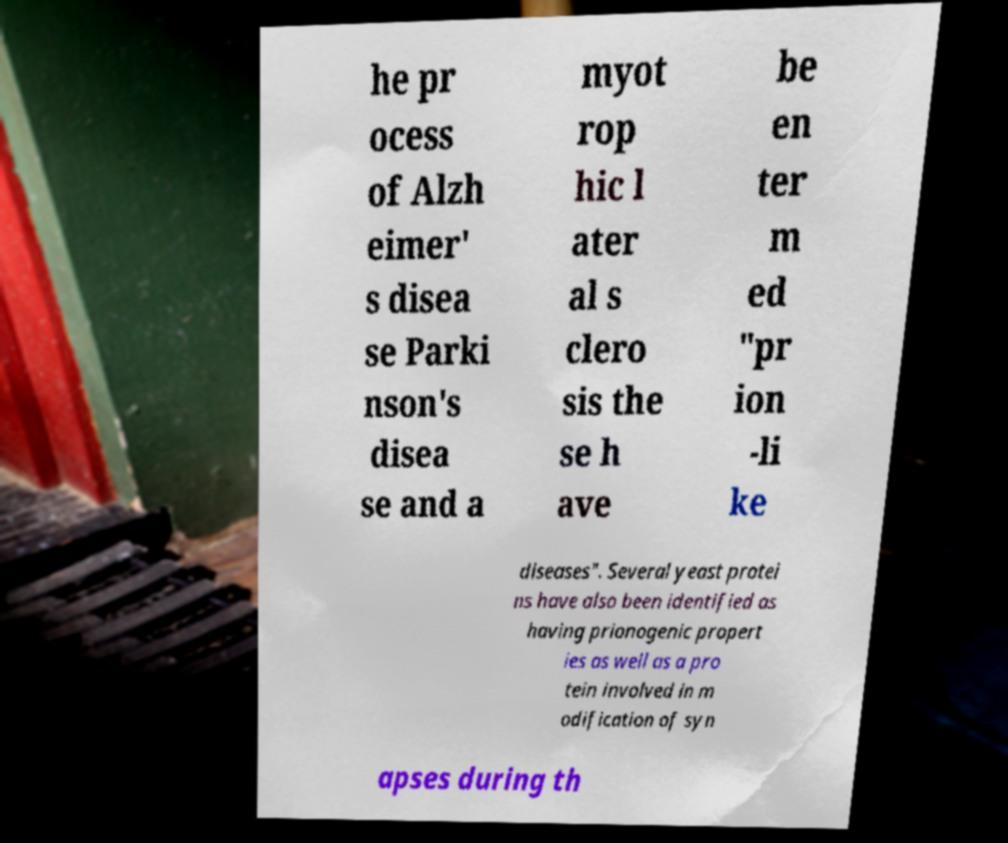Please read and relay the text visible in this image. What does it say? he pr ocess of Alzh eimer' s disea se Parki nson's disea se and a myot rop hic l ater al s clero sis the se h ave be en ter m ed "pr ion -li ke diseases". Several yeast protei ns have also been identified as having prionogenic propert ies as well as a pro tein involved in m odification of syn apses during th 